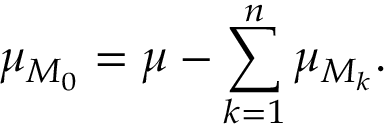Convert formula to latex. <formula><loc_0><loc_0><loc_500><loc_500>\mu _ { M _ { 0 } } = \mu - \sum _ { k = 1 } ^ { n } \mu _ { M _ { k } } .</formula> 